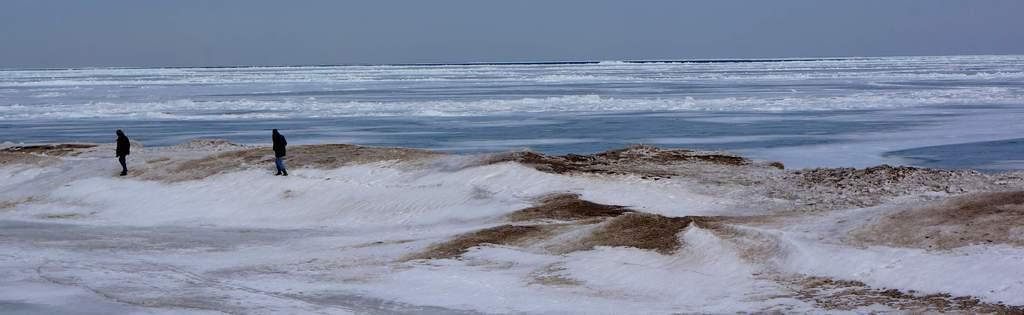How many people are in the image? There are two persons in the image. What are the persons wearing? The persons are wearing clothes. Where are the persons standing? The persons are standing on the beach. What is visible at the top of the image? The sky is visible at the top of the image. What type of lamp can be seen on the beach in the image? There is no lamp present in the image; it features two persons standing on the beach. 